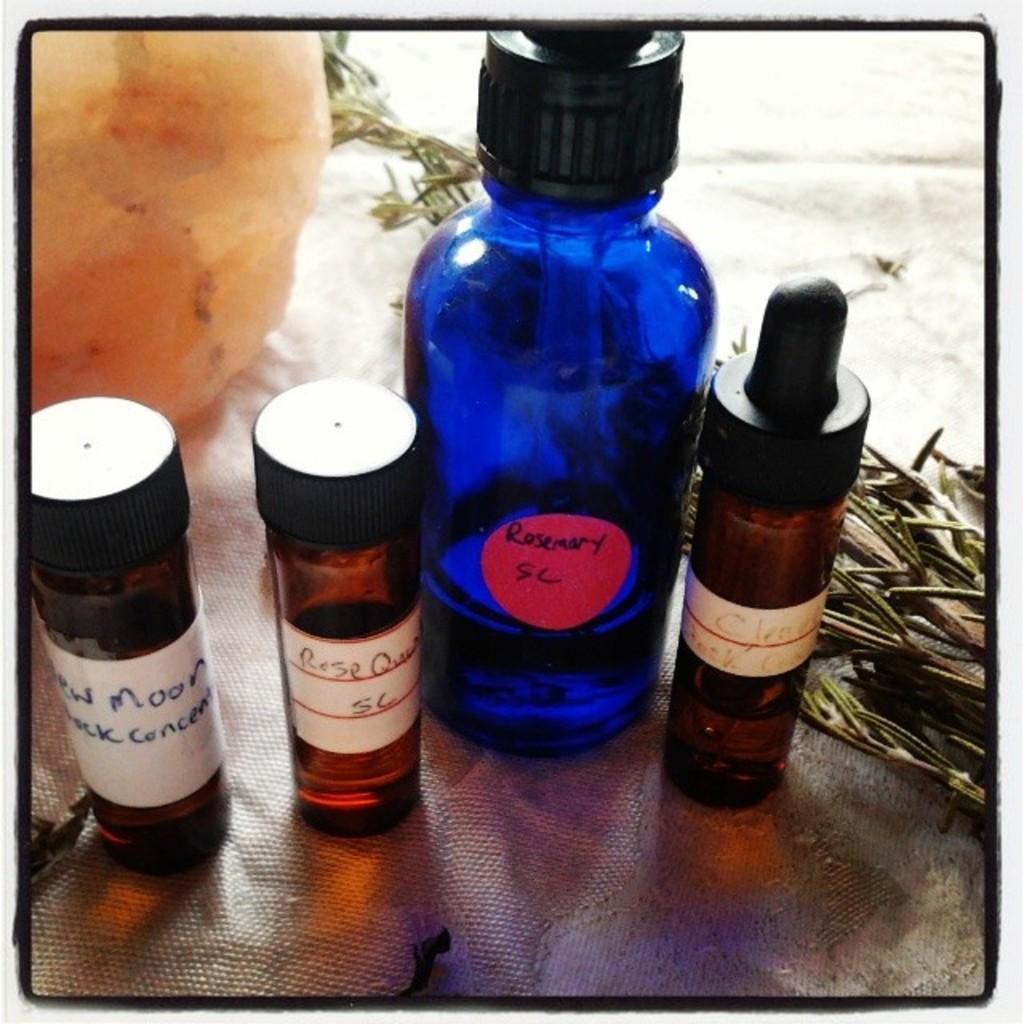Describe this image in one or two sentences. In the picture there are four bottles present in the sheet there are herbs present near the bottle. 